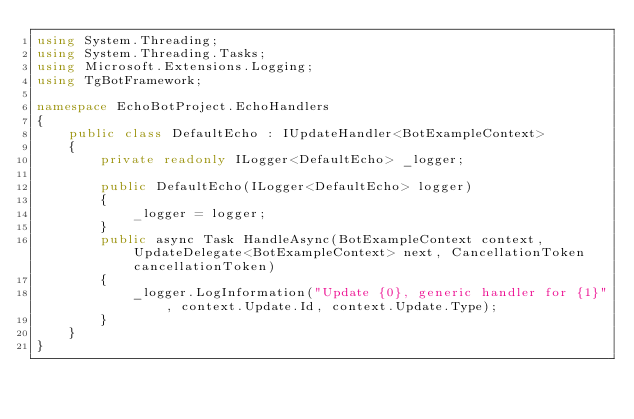Convert code to text. <code><loc_0><loc_0><loc_500><loc_500><_C#_>using System.Threading;
using System.Threading.Tasks;
using Microsoft.Extensions.Logging;
using TgBotFramework;

namespace EchoBotProject.EchoHandlers
{
    public class DefaultEcho : IUpdateHandler<BotExampleContext>
    {
        private readonly ILogger<DefaultEcho> _logger;

        public DefaultEcho(ILogger<DefaultEcho> logger)
        {
            _logger = logger;
        }
        public async Task HandleAsync(BotExampleContext context, UpdateDelegate<BotExampleContext> next, CancellationToken cancellationToken)
        {
            _logger.LogInformation("Update {0}, generic handler for {1}", context.Update.Id, context.Update.Type);
        }
    }
}</code> 